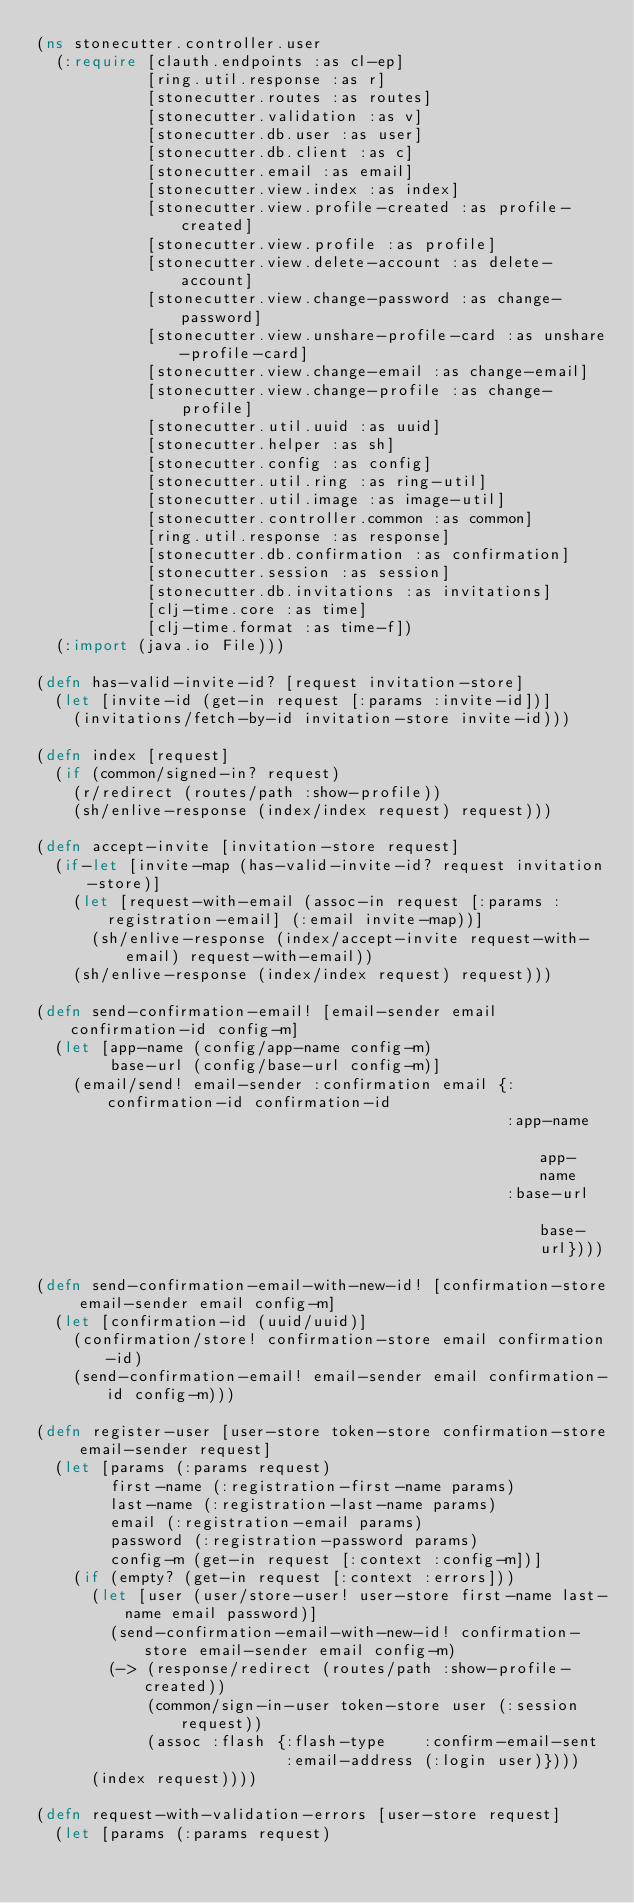Convert code to text. <code><loc_0><loc_0><loc_500><loc_500><_Clojure_>(ns stonecutter.controller.user
  (:require [clauth.endpoints :as cl-ep]
            [ring.util.response :as r]
            [stonecutter.routes :as routes]
            [stonecutter.validation :as v]
            [stonecutter.db.user :as user]
            [stonecutter.db.client :as c]
            [stonecutter.email :as email]
            [stonecutter.view.index :as index]
            [stonecutter.view.profile-created :as profile-created]
            [stonecutter.view.profile :as profile]
            [stonecutter.view.delete-account :as delete-account]
            [stonecutter.view.change-password :as change-password]
            [stonecutter.view.unshare-profile-card :as unshare-profile-card]
            [stonecutter.view.change-email :as change-email]
            [stonecutter.view.change-profile :as change-profile]
            [stonecutter.util.uuid :as uuid]
            [stonecutter.helper :as sh]
            [stonecutter.config :as config]
            [stonecutter.util.ring :as ring-util]
            [stonecutter.util.image :as image-util]
            [stonecutter.controller.common :as common]
            [ring.util.response :as response]
            [stonecutter.db.confirmation :as confirmation]
            [stonecutter.session :as session]
            [stonecutter.db.invitations :as invitations]
            [clj-time.core :as time]
            [clj-time.format :as time-f])
  (:import (java.io File)))

(defn has-valid-invite-id? [request invitation-store]
  (let [invite-id (get-in request [:params :invite-id])]
    (invitations/fetch-by-id invitation-store invite-id)))

(defn index [request]
  (if (common/signed-in? request)
    (r/redirect (routes/path :show-profile))
    (sh/enlive-response (index/index request) request)))

(defn accept-invite [invitation-store request]
  (if-let [invite-map (has-valid-invite-id? request invitation-store)]
    (let [request-with-email (assoc-in request [:params :registration-email] (:email invite-map))]
      (sh/enlive-response (index/accept-invite request-with-email) request-with-email))
    (sh/enlive-response (index/index request) request)))

(defn send-confirmation-email! [email-sender email confirmation-id config-m]
  (let [app-name (config/app-name config-m)
        base-url (config/base-url config-m)]
    (email/send! email-sender :confirmation email {:confirmation-id confirmation-id
                                                   :app-name        app-name
                                                   :base-url        base-url})))

(defn send-confirmation-email-with-new-id! [confirmation-store email-sender email config-m]
  (let [confirmation-id (uuid/uuid)]
    (confirmation/store! confirmation-store email confirmation-id)
    (send-confirmation-email! email-sender email confirmation-id config-m)))

(defn register-user [user-store token-store confirmation-store email-sender request]
  (let [params (:params request)
        first-name (:registration-first-name params)
        last-name (:registration-last-name params)
        email (:registration-email params)
        password (:registration-password params)
        config-m (get-in request [:context :config-m])]
    (if (empty? (get-in request [:context :errors]))
      (let [user (user/store-user! user-store first-name last-name email password)]
        (send-confirmation-email-with-new-id! confirmation-store email-sender email config-m)
        (-> (response/redirect (routes/path :show-profile-created))
            (common/sign-in-user token-store user (:session request))
            (assoc :flash {:flash-type    :confirm-email-sent
                           :email-address (:login user)})))
      (index request))))

(defn request-with-validation-errors [user-store request]
  (let [params (:params request)</code> 